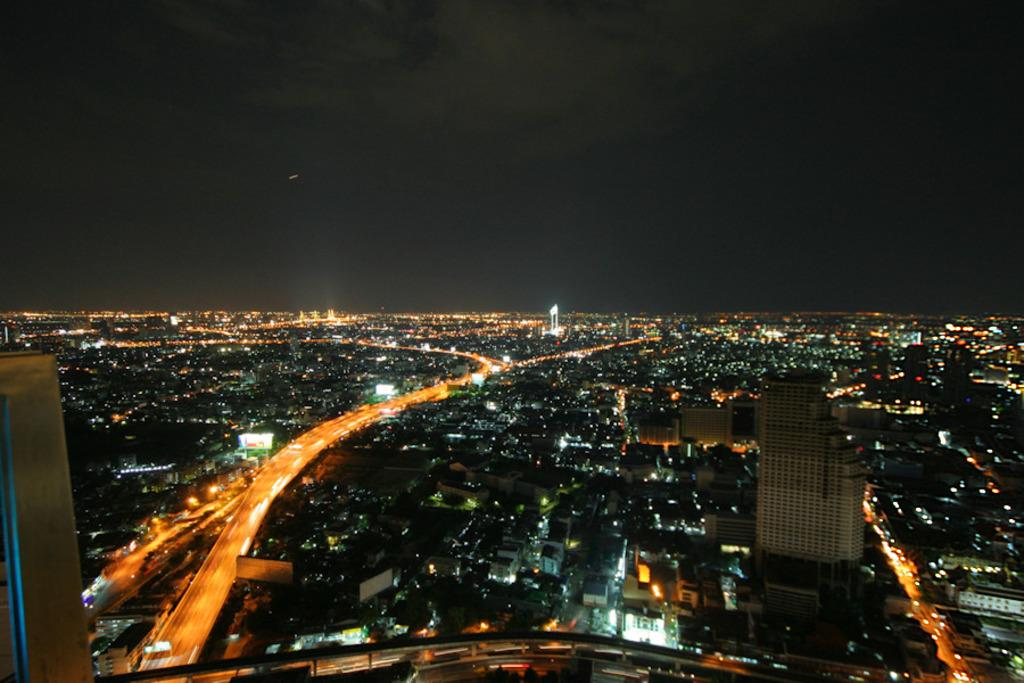What type of structures can be seen in the image? There are buildings in the image. What else is visible in the image besides the buildings? There are lights visible in the image. What can be seen in the background of the image? The sky is visible in the background of the image. Can you see a shoe hanging from the building in the image? There is no shoe hanging from the building in the image. Is there a cat visible on the roof of one of the buildings in the image? There is no cat visible on the roof of any of the buildings in the image. 